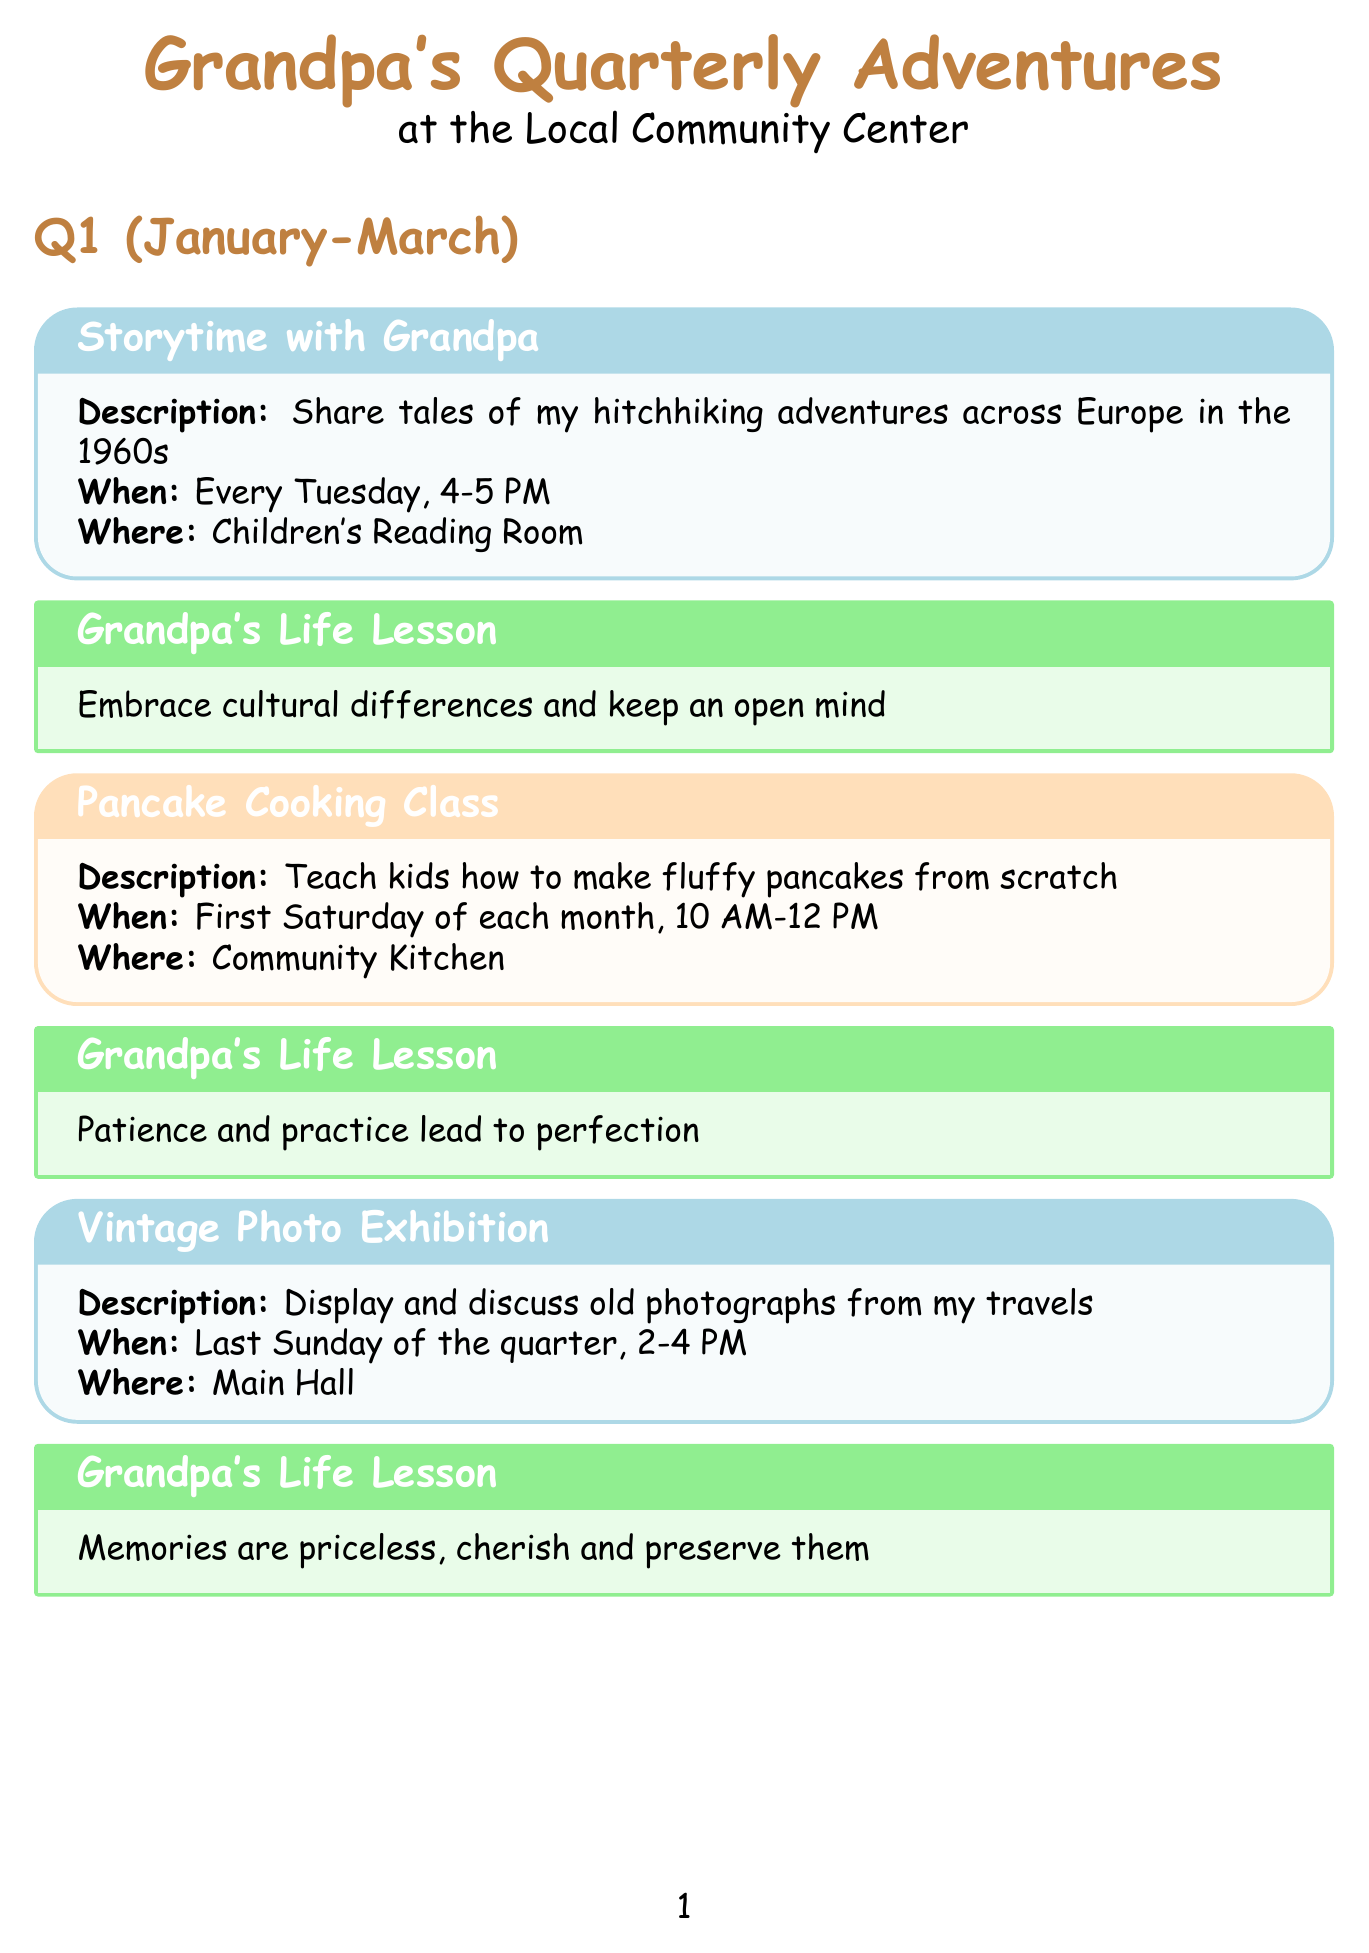What is the first activity in Q1? The first activity listed in Q1 is "Storytime with Grandpa."
Answer: Storytime with Grandpa How often is the Pancake Cooking Class held? The Pancake Cooking Class takes place on the first Saturday of each month.
Answer: First Saturday of each month When is the Father's Day Special activity scheduled? The Father's Day Special: Life Wisdom Session is scheduled for June 18th.
Answer: June 18th What life lesson is associated with the Gardening Workshop? The life lesson connected to the Gardening Workshop is about growth taking time and care.
Answer: Growth takes time and care, in plants and in life How many activities are scheduled in Q4? There are three activities scheduled in Q4.
Answer: Three What is the common theme of the activities in Q3? The activities in Q3 focus on storytelling and reading.
Answer: Storytelling and reading Where does the Summer Reading Challenge take place? The Summer Reading Challenge is held in the Library.
Answer: Library Which activity is scheduled for November 23rd? The activity scheduled for November 23rd is the Thanksgiving Gratitude Circle.
Answer: Thanksgiving Gratitude Circle What is the frequency of the Halloween Special activity? The Halloween Special occurs on two consecutive nights, October 30th and 31st.
Answer: October 30th and 31st 